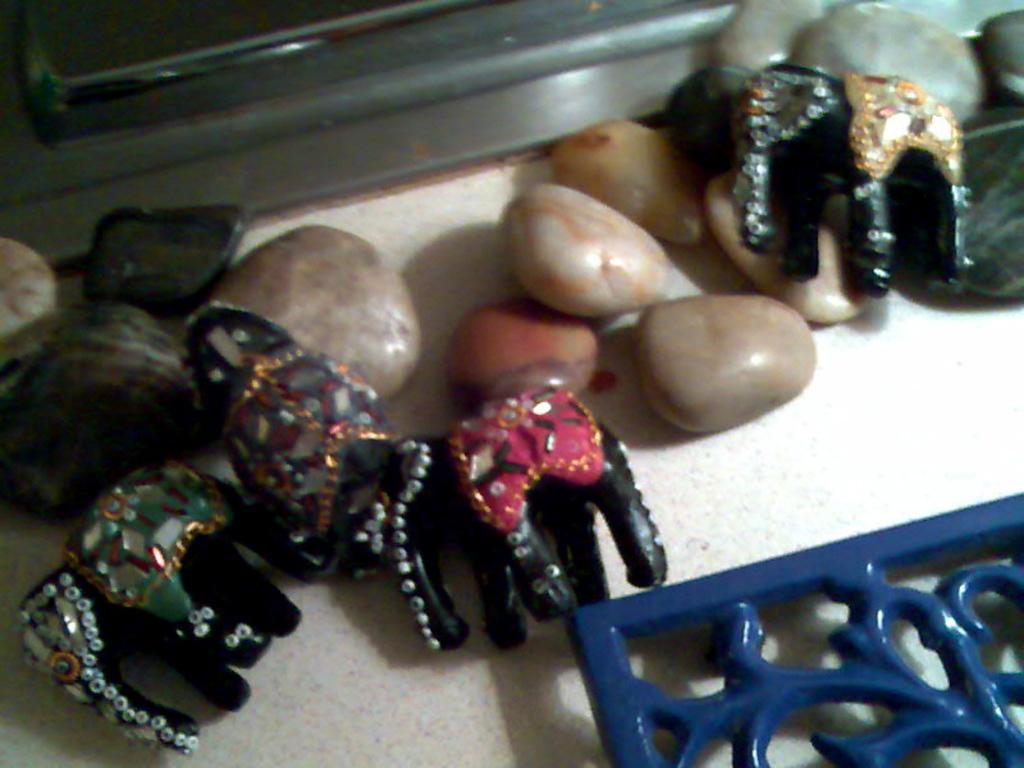Please provide a concise description of this image. In this picture I can see there are few elephant dolls and there are few pebbles and there is a blue color frame at right bottom. 